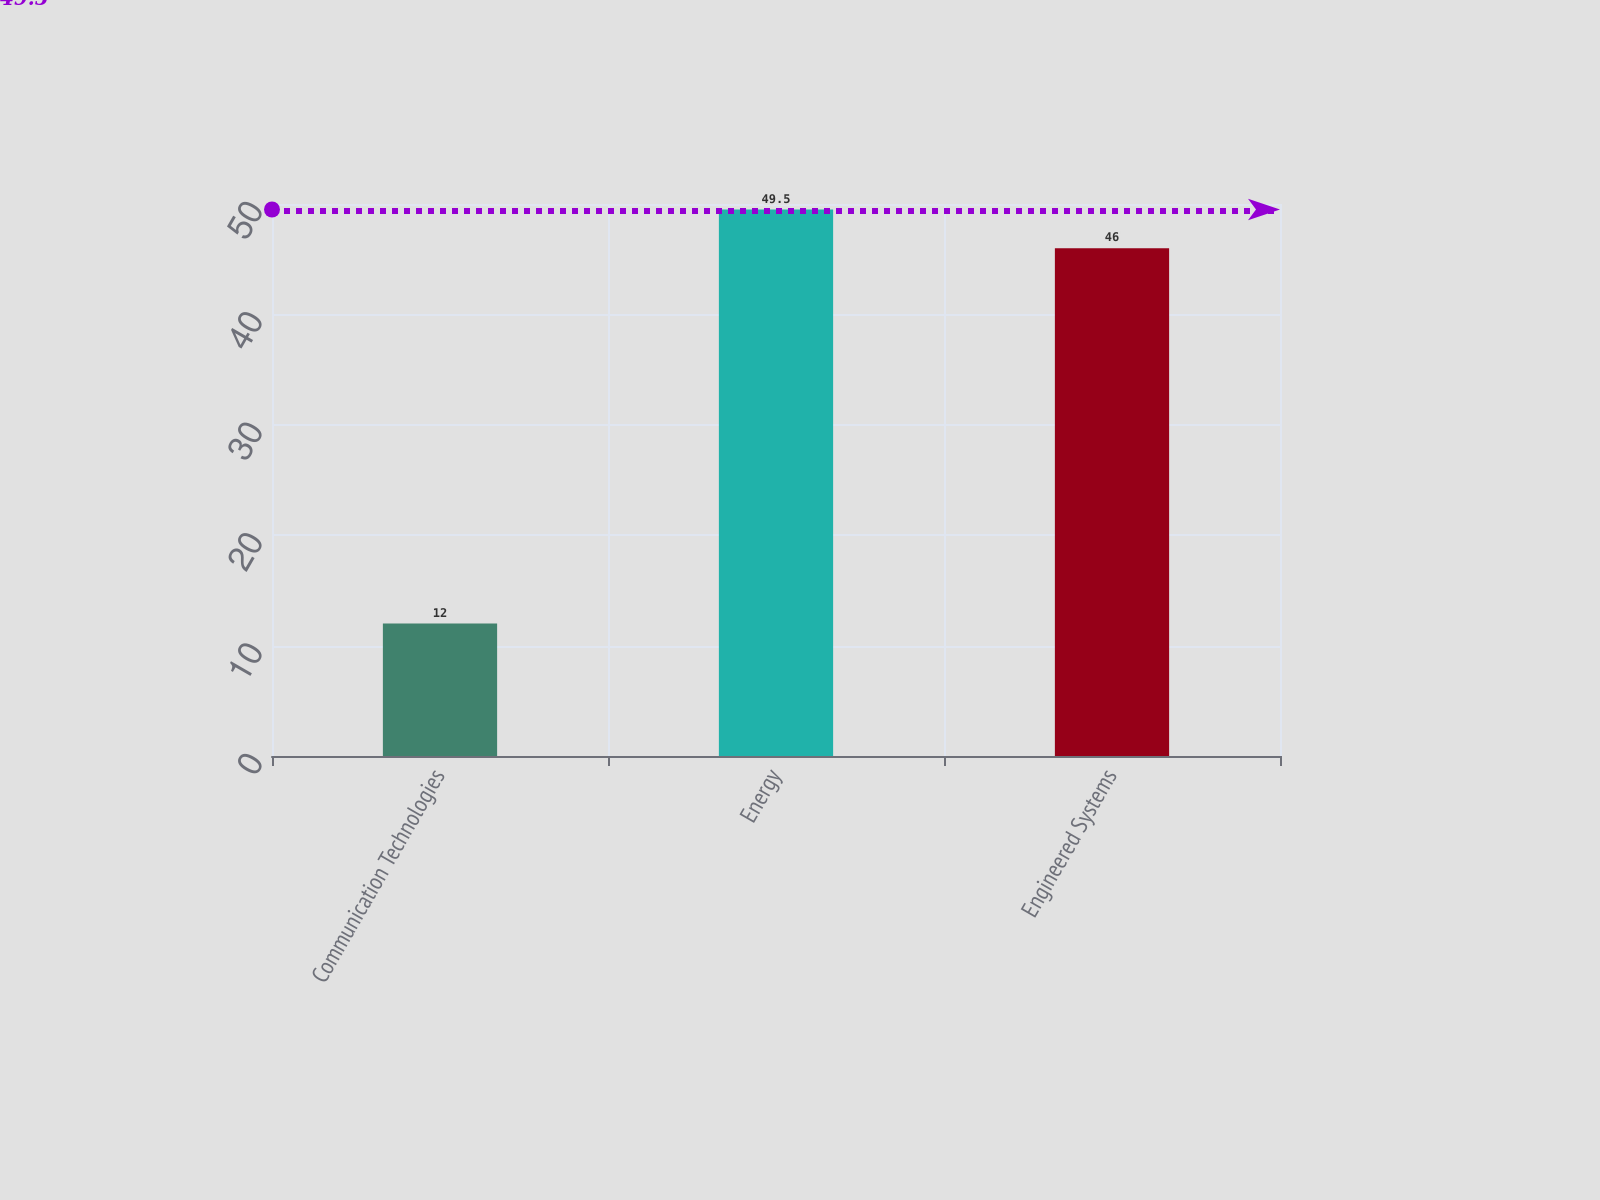Convert chart. <chart><loc_0><loc_0><loc_500><loc_500><bar_chart><fcel>Communication Technologies<fcel>Energy<fcel>Engineered Systems<nl><fcel>12<fcel>49.5<fcel>46<nl></chart> 